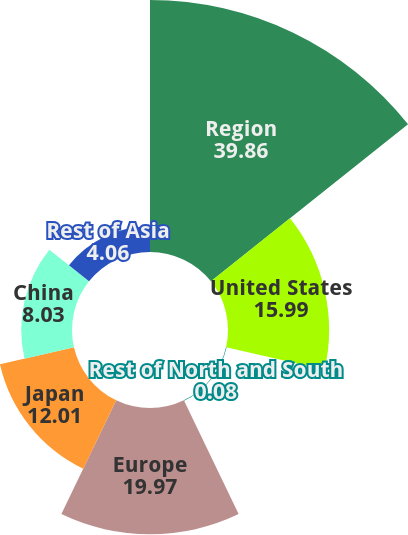Convert chart to OTSL. <chart><loc_0><loc_0><loc_500><loc_500><pie_chart><fcel>Region<fcel>United States<fcel>Rest of North and South<fcel>Europe<fcel>Japan<fcel>China<fcel>Rest of Asia<nl><fcel>39.86%<fcel>15.99%<fcel>0.08%<fcel>19.97%<fcel>12.01%<fcel>8.03%<fcel>4.06%<nl></chart> 